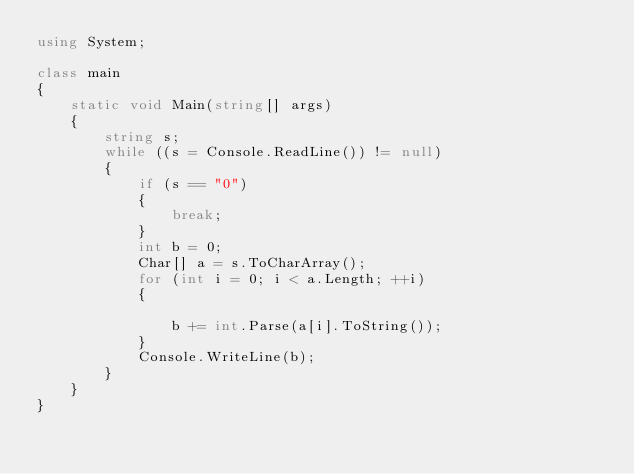<code> <loc_0><loc_0><loc_500><loc_500><_C#_>using System;

class main
{
    static void Main(string[] args)
    {
        string s;
        while ((s = Console.ReadLine()) != null)
        {
            if (s == "0")
            {
                break;
            }
            int b = 0;
            Char[] a = s.ToCharArray();
            for (int i = 0; i < a.Length; ++i)
            {

                b += int.Parse(a[i].ToString());
            }
            Console.WriteLine(b);
        }
    }
}</code> 